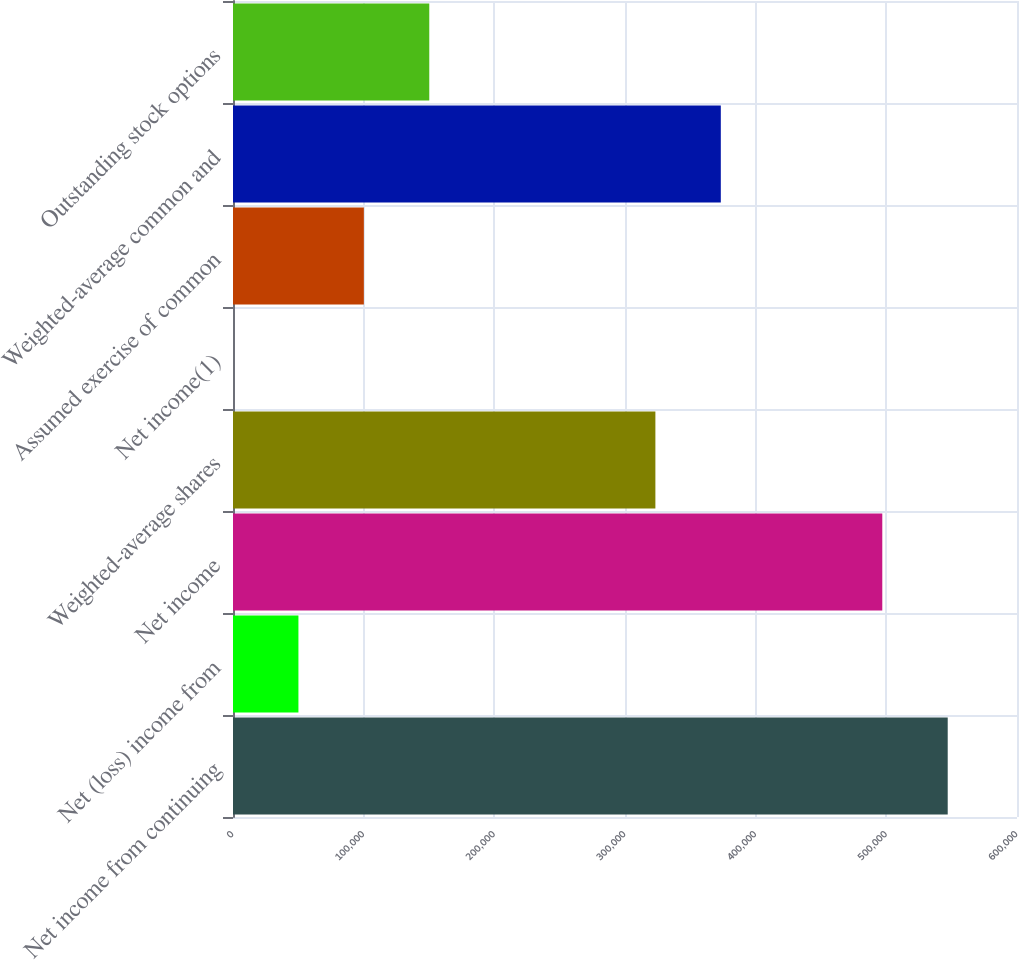Convert chart. <chart><loc_0><loc_0><loc_500><loc_500><bar_chart><fcel>Net income from continuing<fcel>Net (loss) income from<fcel>Net income<fcel>Weighted-average shares<fcel>Net income(1)<fcel>Assumed exercise of common<fcel>Weighted-average common and<fcel>Outstanding stock options<nl><fcel>546976<fcel>50070.9<fcel>496907<fcel>323255<fcel>1.54<fcel>100140<fcel>373324<fcel>150210<nl></chart> 